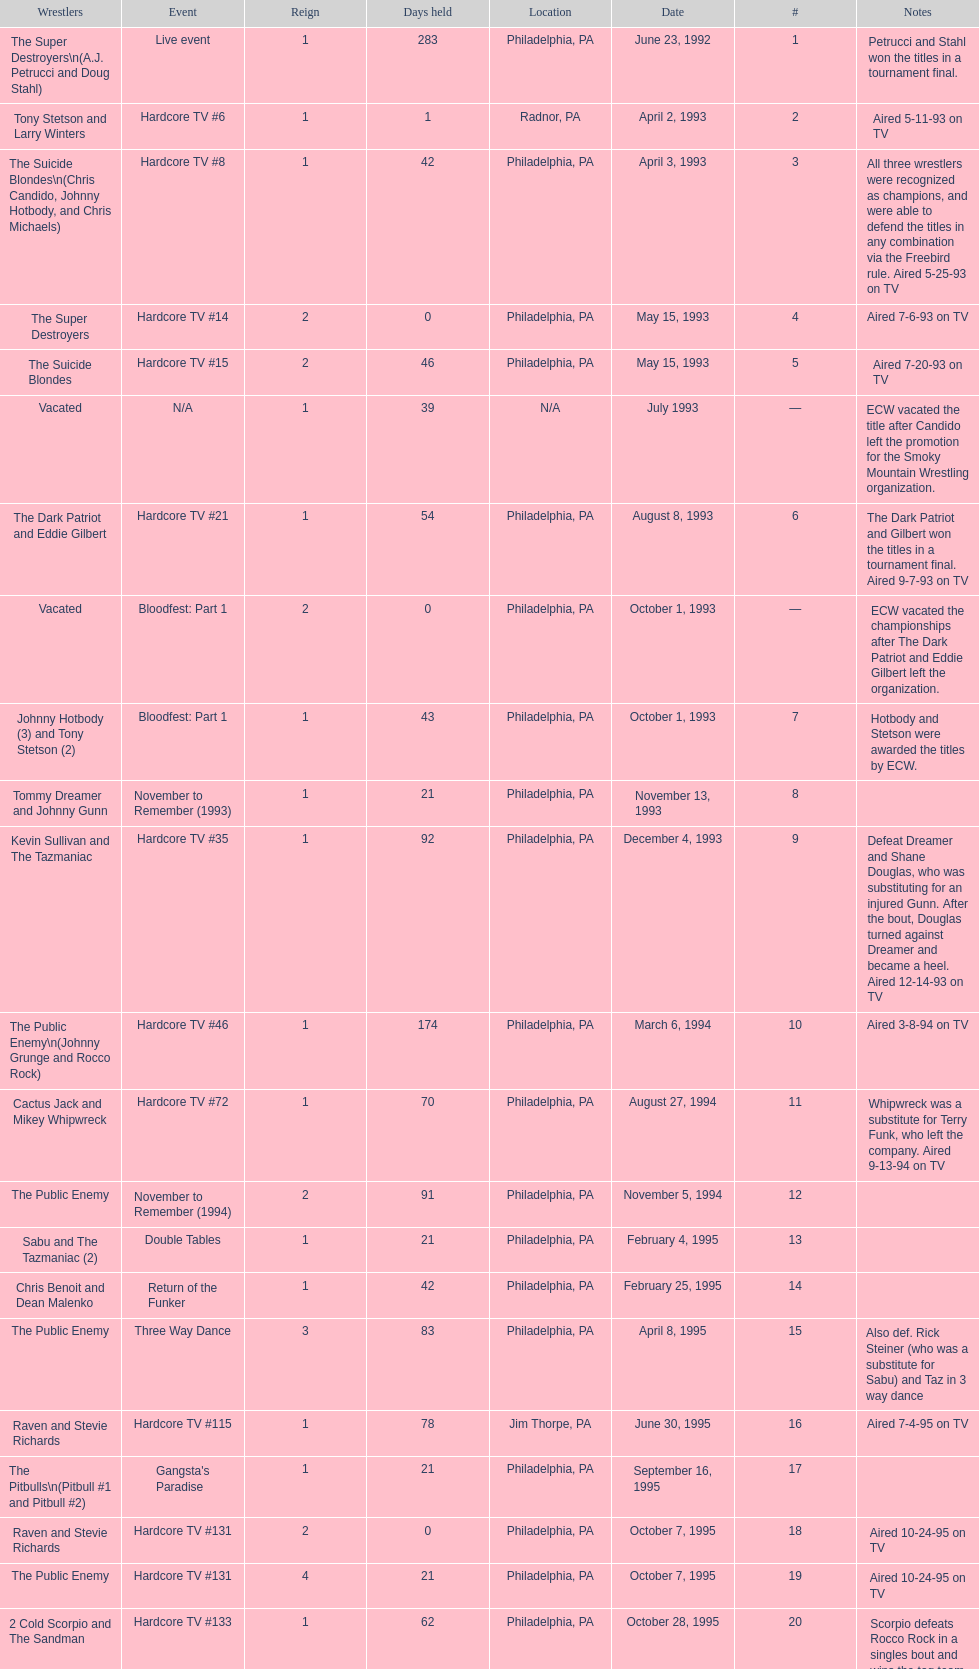How many times, from june 23, 1992 to december 3, 2000, did the suicide blondes hold the title? 2. 